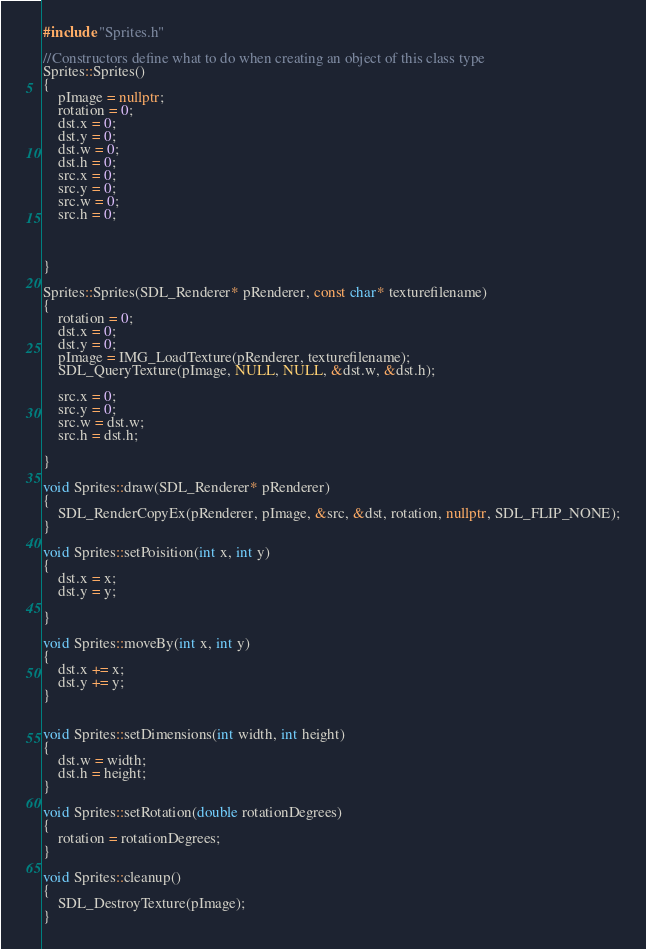Convert code to text. <code><loc_0><loc_0><loc_500><loc_500><_C++_>#include "Sprites.h"

//Constructors define what to do when creating an object of this class type
Sprites::Sprites()
{
	pImage = nullptr;
	rotation = 0;
	dst.x = 0;
	dst.y = 0;
	dst.w = 0;
	dst.h = 0;
	src.x = 0;
	src.y = 0;
	src.w = 0;
	src.h = 0;



}

Sprites::Sprites(SDL_Renderer* pRenderer, const char* texturefilename)
{
	rotation = 0;
	dst.x = 0;
	dst.y = 0;
	pImage = IMG_LoadTexture(pRenderer, texturefilename);
	SDL_QueryTexture(pImage, NULL, NULL, &dst.w, &dst.h);

	src.x = 0;
	src.y = 0;
	src.w = dst.w;
	src.h = dst.h;

}

void Sprites::draw(SDL_Renderer* pRenderer)
{
	SDL_RenderCopyEx(pRenderer, pImage, &src, &dst, rotation, nullptr, SDL_FLIP_NONE);
}

void Sprites::setPoisition(int x, int y)
{
	dst.x = x;
	dst.y = y;

}

void Sprites::moveBy(int x, int y)
{
	dst.x += x;
	dst.y += y;
}


void Sprites::setDimensions(int width, int height)
{
	dst.w = width;
	dst.h = height;
}

void Sprites::setRotation(double rotationDegrees)
{
	rotation = rotationDegrees;
}

void Sprites::cleanup()
{
	SDL_DestroyTexture(pImage);
}

</code> 